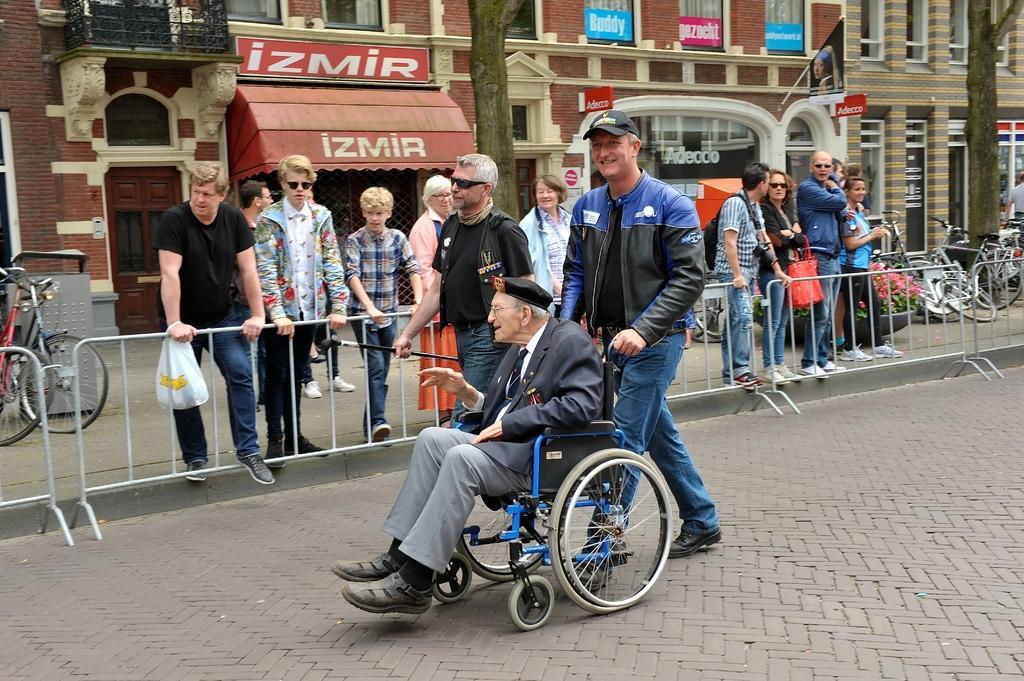Describe this image in one or two sentences. In this image we can see a man on the wheelchair. We can also see another man pushing the wheelchair. In the background, we can see many people standing near the barrier. We can also see the trees, bicycles and also the buildings and a flag. At the bottom we can see the path. We can also see the flower pots. 